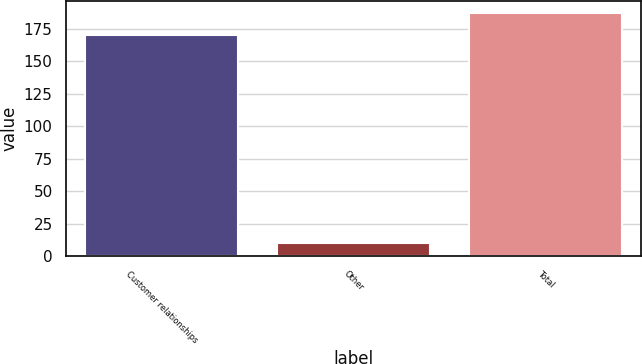Convert chart. <chart><loc_0><loc_0><loc_500><loc_500><bar_chart><fcel>Customer relationships<fcel>Other<fcel>Total<nl><fcel>170<fcel>10<fcel>187<nl></chart> 